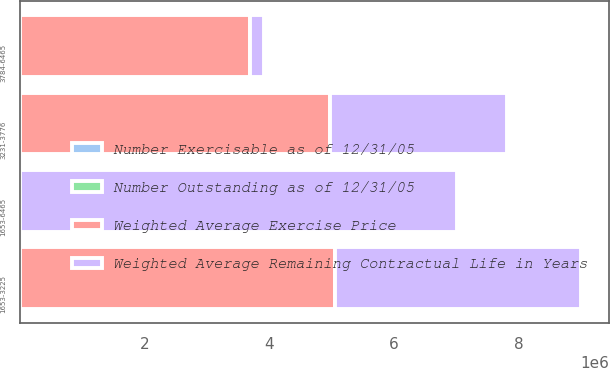Convert chart to OTSL. <chart><loc_0><loc_0><loc_500><loc_500><stacked_bar_chart><ecel><fcel>1653-3225<fcel>3231-3776<fcel>3784-6465<fcel>1653-6465<nl><fcel>Weighted Average Exercise Price<fcel>5.0507e+06<fcel>4.98079e+06<fcel>3.69363e+06<fcel>54.09<nl><fcel>Number Exercisable as of 12/31/05<fcel>4.8<fcel>6.8<fcel>8.9<fcel>6.6<nl><fcel>Number Outstanding as of 12/31/05<fcel>28.19<fcel>35.55<fcel>54.09<fcel>37.83<nl><fcel>Weighted Average Remaining Contractual Life in Years<fcel>3.951e+06<fcel>2.83067e+06<fcel>220271<fcel>7.00194e+06<nl></chart> 